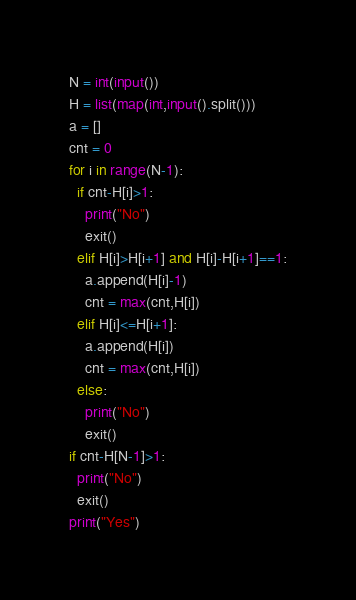Convert code to text. <code><loc_0><loc_0><loc_500><loc_500><_Python_>N = int(input())
H = list(map(int,input().split()))
a = []
cnt = 0
for i in range(N-1):
  if cnt-H[i]>1:
    print("No")
    exit() 
  elif H[i]>H[i+1] and H[i]-H[i+1]==1:
    a.append(H[i]-1)
    cnt = max(cnt,H[i])
  elif H[i]<=H[i+1]:
    a.append(H[i])
    cnt = max(cnt,H[i])
  else:
    print("No")
    exit()
if cnt-H[N-1]>1:
  print("No")
  exit()
print("Yes")
</code> 